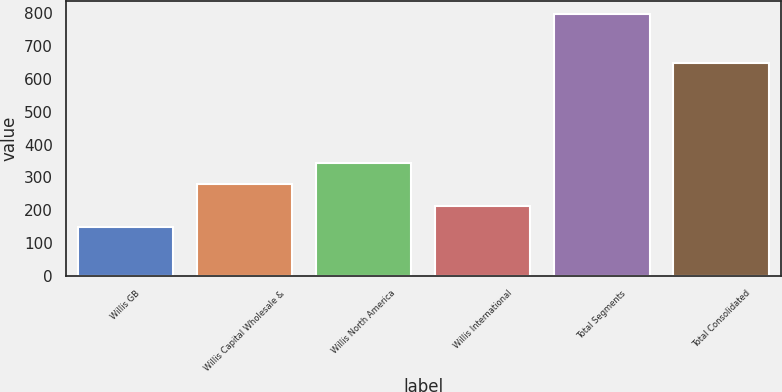Convert chart to OTSL. <chart><loc_0><loc_0><loc_500><loc_500><bar_chart><fcel>Willis GB<fcel>Willis Capital Wholesale &<fcel>Willis North America<fcel>Willis International<fcel>Total Segments<fcel>Total Consolidated<nl><fcel>148<fcel>278.2<fcel>343.3<fcel>213.1<fcel>799<fcel>647<nl></chart> 